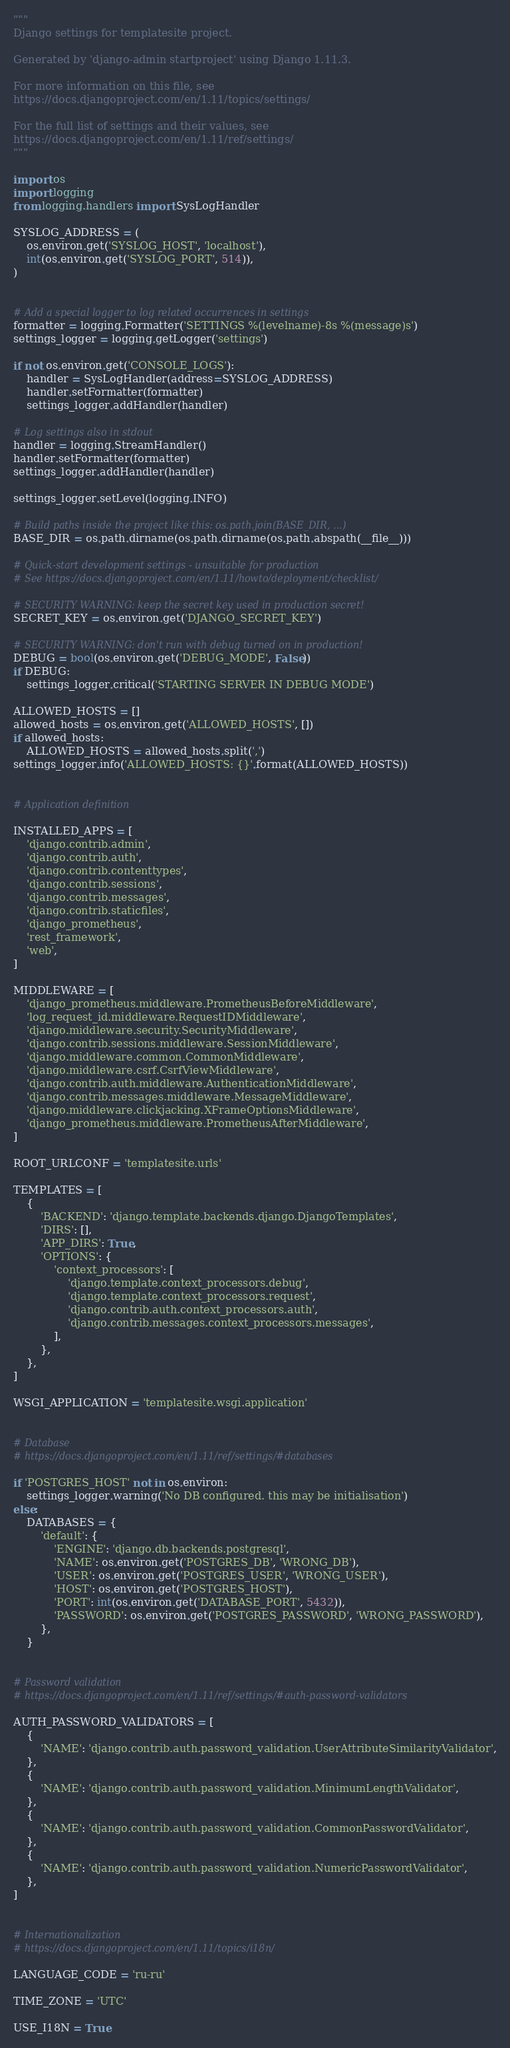Convert code to text. <code><loc_0><loc_0><loc_500><loc_500><_Python_>"""
Django settings for templatesite project.

Generated by 'django-admin startproject' using Django 1.11.3.

For more information on this file, see
https://docs.djangoproject.com/en/1.11/topics/settings/

For the full list of settings and their values, see
https://docs.djangoproject.com/en/1.11/ref/settings/
"""

import os
import logging
from logging.handlers import SysLogHandler

SYSLOG_ADDRESS = (
    os.environ.get('SYSLOG_HOST', 'localhost'),
    int(os.environ.get('SYSLOG_PORT', 514)),
)


# Add a special logger to log related occurrences in settings
formatter = logging.Formatter('SETTINGS %(levelname)-8s %(message)s')
settings_logger = logging.getLogger('settings')

if not os.environ.get('CONSOLE_LOGS'):
    handler = SysLogHandler(address=SYSLOG_ADDRESS)
    handler.setFormatter(formatter)
    settings_logger.addHandler(handler)

# Log settings also in stdout
handler = logging.StreamHandler()
handler.setFormatter(formatter)
settings_logger.addHandler(handler)

settings_logger.setLevel(logging.INFO)

# Build paths inside the project like this: os.path.join(BASE_DIR, ...)
BASE_DIR = os.path.dirname(os.path.dirname(os.path.abspath(__file__)))

# Quick-start development settings - unsuitable for production
# See https://docs.djangoproject.com/en/1.11/howto/deployment/checklist/

# SECURITY WARNING: keep the secret key used in production secret!
SECRET_KEY = os.environ.get('DJANGO_SECRET_KEY')

# SECURITY WARNING: don't run with debug turned on in production!
DEBUG = bool(os.environ.get('DEBUG_MODE', False))
if DEBUG:
    settings_logger.critical('STARTING SERVER IN DEBUG MODE')

ALLOWED_HOSTS = []
allowed_hosts = os.environ.get('ALLOWED_HOSTS', [])
if allowed_hosts:
    ALLOWED_HOSTS = allowed_hosts.split(',')
settings_logger.info('ALLOWED_HOSTS: {}'.format(ALLOWED_HOSTS))


# Application definition

INSTALLED_APPS = [
    'django.contrib.admin',
    'django.contrib.auth',
    'django.contrib.contenttypes',
    'django.contrib.sessions',
    'django.contrib.messages',
    'django.contrib.staticfiles',
    'django_prometheus',
    'rest_framework',
    'web',
]

MIDDLEWARE = [
    'django_prometheus.middleware.PrometheusBeforeMiddleware',
    'log_request_id.middleware.RequestIDMiddleware',
    'django.middleware.security.SecurityMiddleware',
    'django.contrib.sessions.middleware.SessionMiddleware',
    'django.middleware.common.CommonMiddleware',
    'django.middleware.csrf.CsrfViewMiddleware',
    'django.contrib.auth.middleware.AuthenticationMiddleware',
    'django.contrib.messages.middleware.MessageMiddleware',
    'django.middleware.clickjacking.XFrameOptionsMiddleware',
    'django_prometheus.middleware.PrometheusAfterMiddleware',
]

ROOT_URLCONF = 'templatesite.urls'

TEMPLATES = [
    {
        'BACKEND': 'django.template.backends.django.DjangoTemplates',
        'DIRS': [],
        'APP_DIRS': True,
        'OPTIONS': {
            'context_processors': [
                'django.template.context_processors.debug',
                'django.template.context_processors.request',
                'django.contrib.auth.context_processors.auth',
                'django.contrib.messages.context_processors.messages',
            ],
        },
    },
]

WSGI_APPLICATION = 'templatesite.wsgi.application'


# Database
# https://docs.djangoproject.com/en/1.11/ref/settings/#databases

if 'POSTGRES_HOST' not in os.environ:
    settings_logger.warning('No DB configured. this may be initialisation')
else:
    DATABASES = {
        'default': {
            'ENGINE': 'django.db.backends.postgresql',
            'NAME': os.environ.get('POSTGRES_DB', 'WRONG_DB'),
            'USER': os.environ.get('POSTGRES_USER', 'WRONG_USER'),
            'HOST': os.environ.get('POSTGRES_HOST'),
            'PORT': int(os.environ.get('DATABASE_PORT', 5432)),
            'PASSWORD': os.environ.get('POSTGRES_PASSWORD', 'WRONG_PASSWORD'),
        },
    }


# Password validation
# https://docs.djangoproject.com/en/1.11/ref/settings/#auth-password-validators

AUTH_PASSWORD_VALIDATORS = [
    {
        'NAME': 'django.contrib.auth.password_validation.UserAttributeSimilarityValidator',
    },
    {
        'NAME': 'django.contrib.auth.password_validation.MinimumLengthValidator',
    },
    {
        'NAME': 'django.contrib.auth.password_validation.CommonPasswordValidator',
    },
    {
        'NAME': 'django.contrib.auth.password_validation.NumericPasswordValidator',
    },
]


# Internationalization
# https://docs.djangoproject.com/en/1.11/topics/i18n/

LANGUAGE_CODE = 'ru-ru'

TIME_ZONE = 'UTC'

USE_I18N = True
</code> 